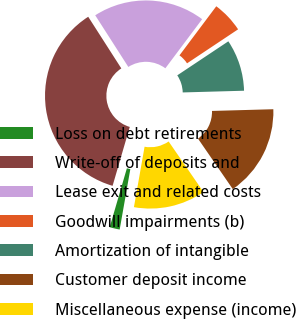<chart> <loc_0><loc_0><loc_500><loc_500><pie_chart><fcel>Loss on debt retirements<fcel>Write-off of deposits and<fcel>Lease exit and related costs<fcel>Goodwill impairments (b)<fcel>Amortization of intangible<fcel>Customer deposit income<fcel>Miscellaneous expense (income)<nl><fcel>1.74%<fcel>36.41%<fcel>19.31%<fcel>5.41%<fcel>8.91%<fcel>15.84%<fcel>12.38%<nl></chart> 